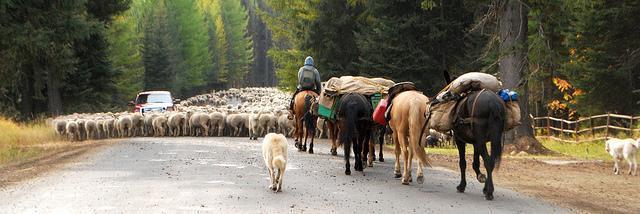How many horses are in the picture?
Give a very brief answer. 3. How many blue ties are there?
Give a very brief answer. 0. 